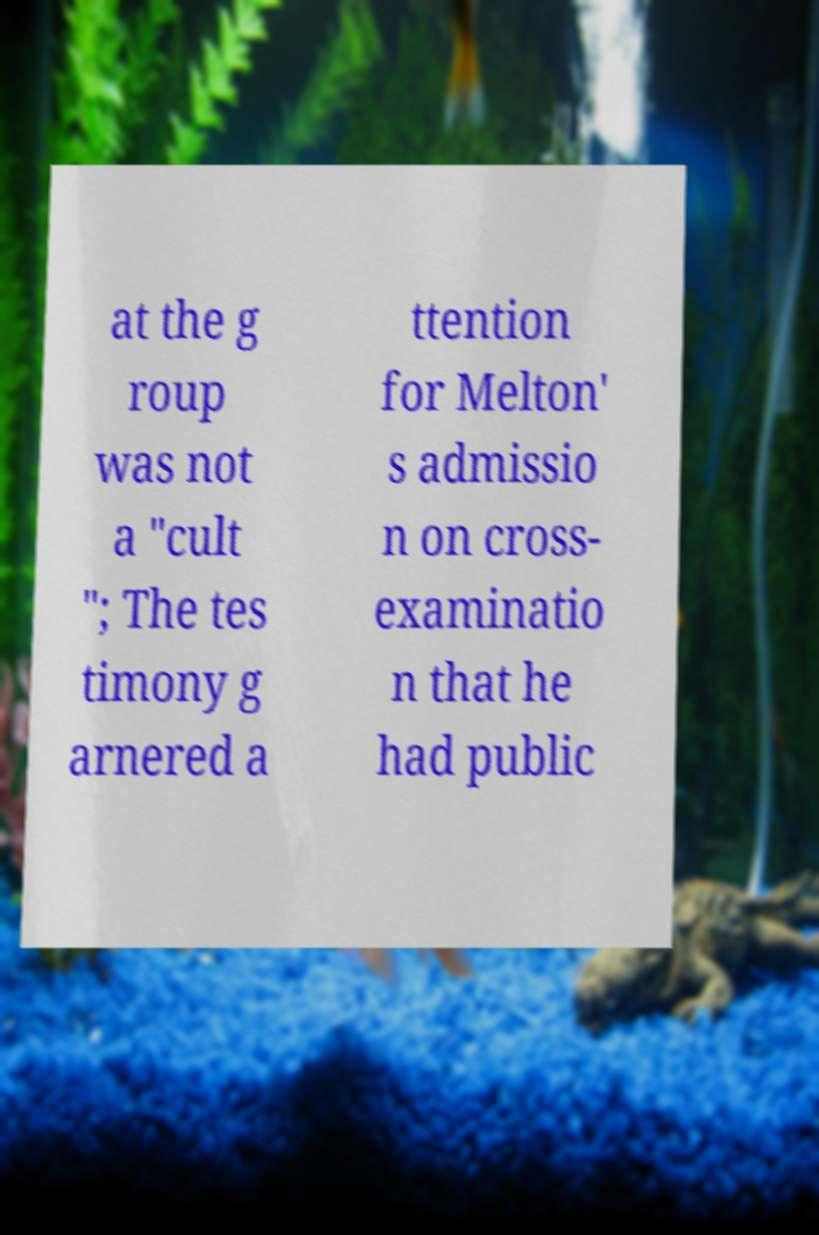Can you read and provide the text displayed in the image?This photo seems to have some interesting text. Can you extract and type it out for me? at the g roup was not a "cult "; The tes timony g arnered a ttention for Melton' s admissio n on cross- examinatio n that he had public 